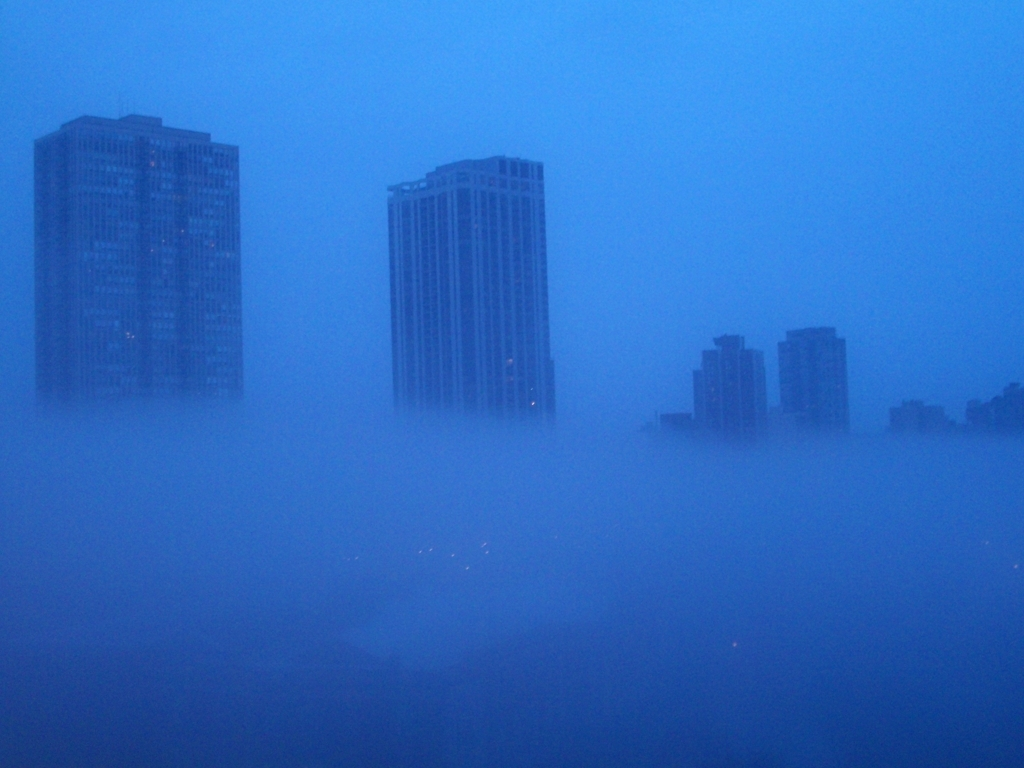Can you describe the weather conditions depicted in this image? The image shows a dense fog descending upon a cityscape, significantly reducing visibility and shrouding the buildings in a mysterious veil. The fog appears to be quite thick, enveloping the structures and only allowing dim lights to filter through, suggesting early morning or evening hours when the city lights are typically visible. 